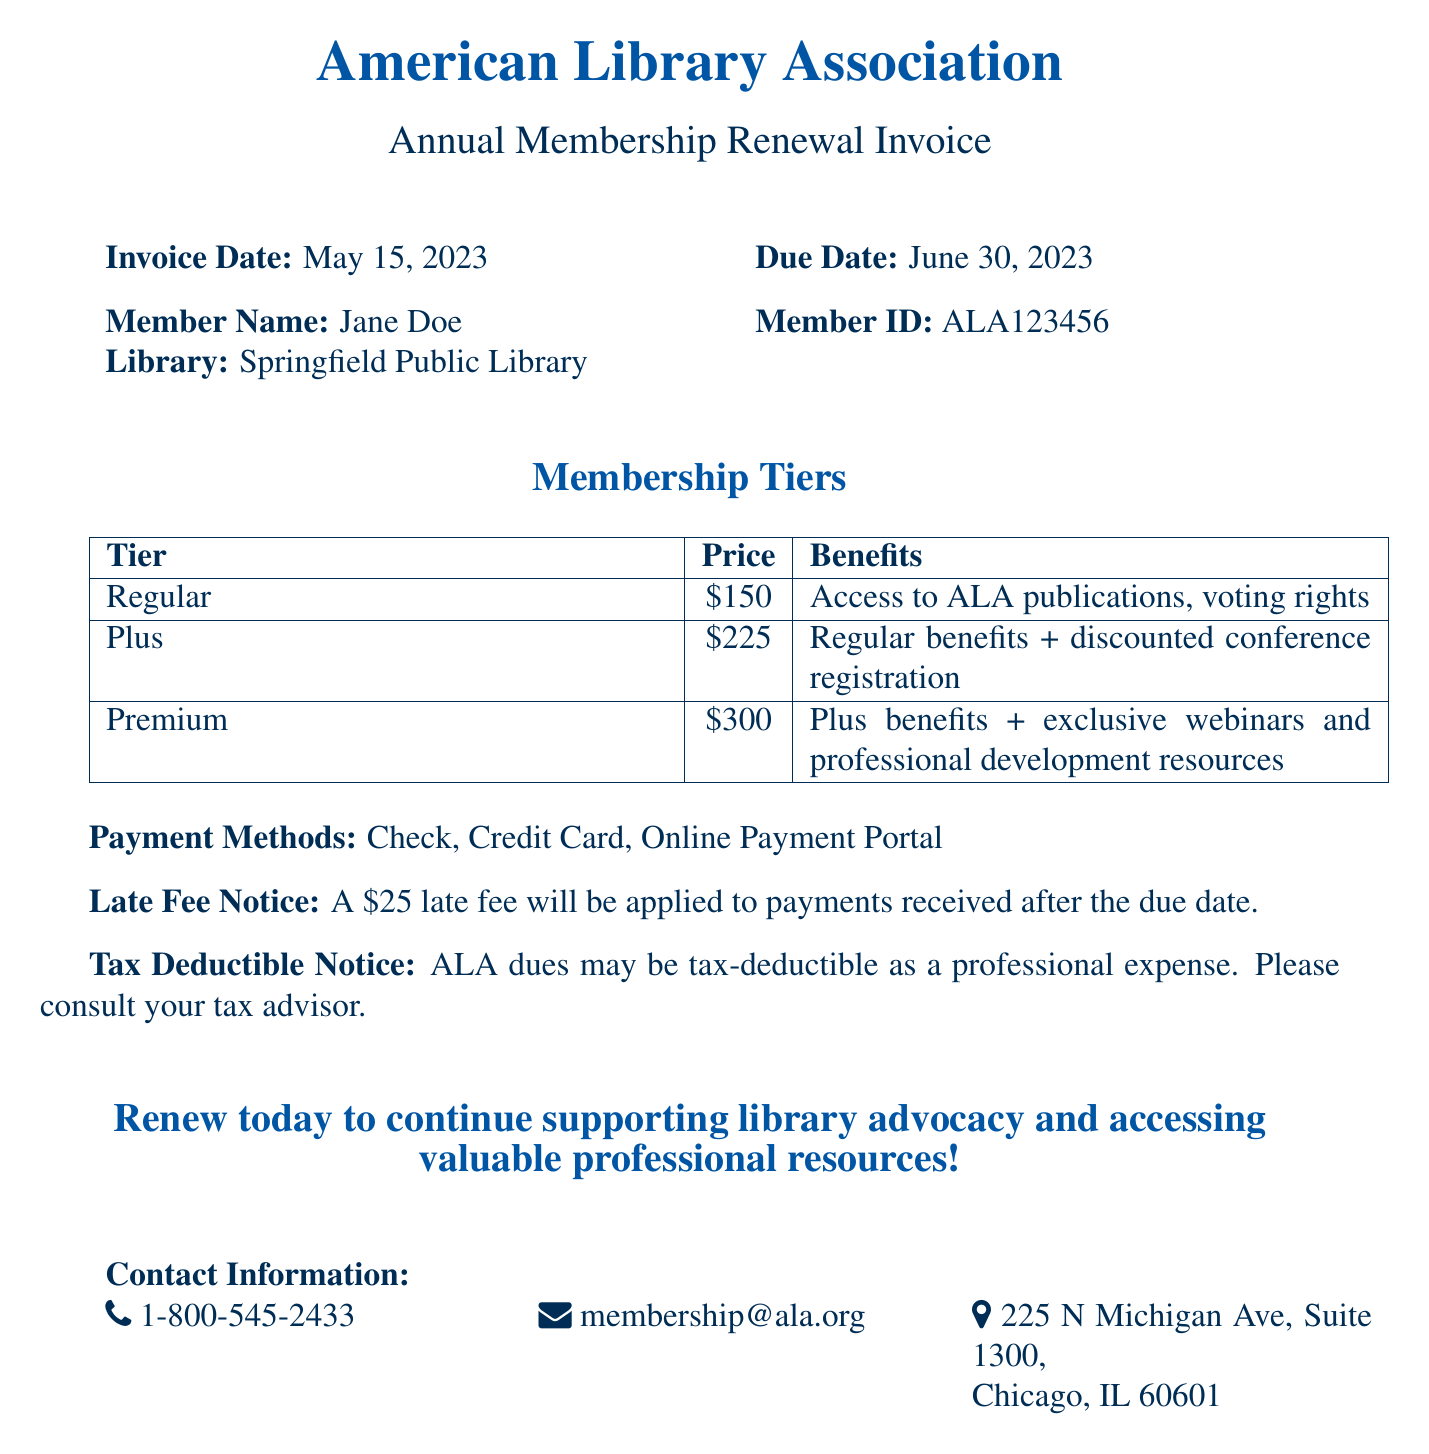What is the invoice date? The invoice date is specified in the document under Invoice Date.
Answer: May 15, 2023 What is the due date for payment? The due date is mentioned in the document in conjunction with the Invoice Date.
Answer: June 30, 2023 What is the member ID? The member ID can be found next to the Member Name in the document.
Answer: ALA123456 What is the price of the Premium membership? The price for the Premium membership is listed in the Membership Tiers section of the document.
Answer: $300 What benefits are included in the Plus membership? The benefits for the Plus membership include information from the Membership Tiers table in the document.
Answer: Regular benefits + discounted conference registration What is the late fee amount? The late fee is indicated in a specific notice about late fees in the document.
Answer: $25 Which payment methods are accepted? The accepted payment methods are listed in the document under Payment Methods.
Answer: Check, Credit Card, Online Payment Portal How can ALA dues be treated for tax purposes? The tax treatment of ALA dues is mentioned in the Tax Deductible Notice section of the document.
Answer: Tax-deductible as a professional expense What is the purpose of renewing the membership? The purpose of renewal is found in the encouraging statement at the end of the document.
Answer: Supporting library advocacy and accessing valuable professional resources 